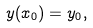Convert formula to latex. <formula><loc_0><loc_0><loc_500><loc_500>y ( x _ { 0 } ) = y _ { 0 } ,</formula> 